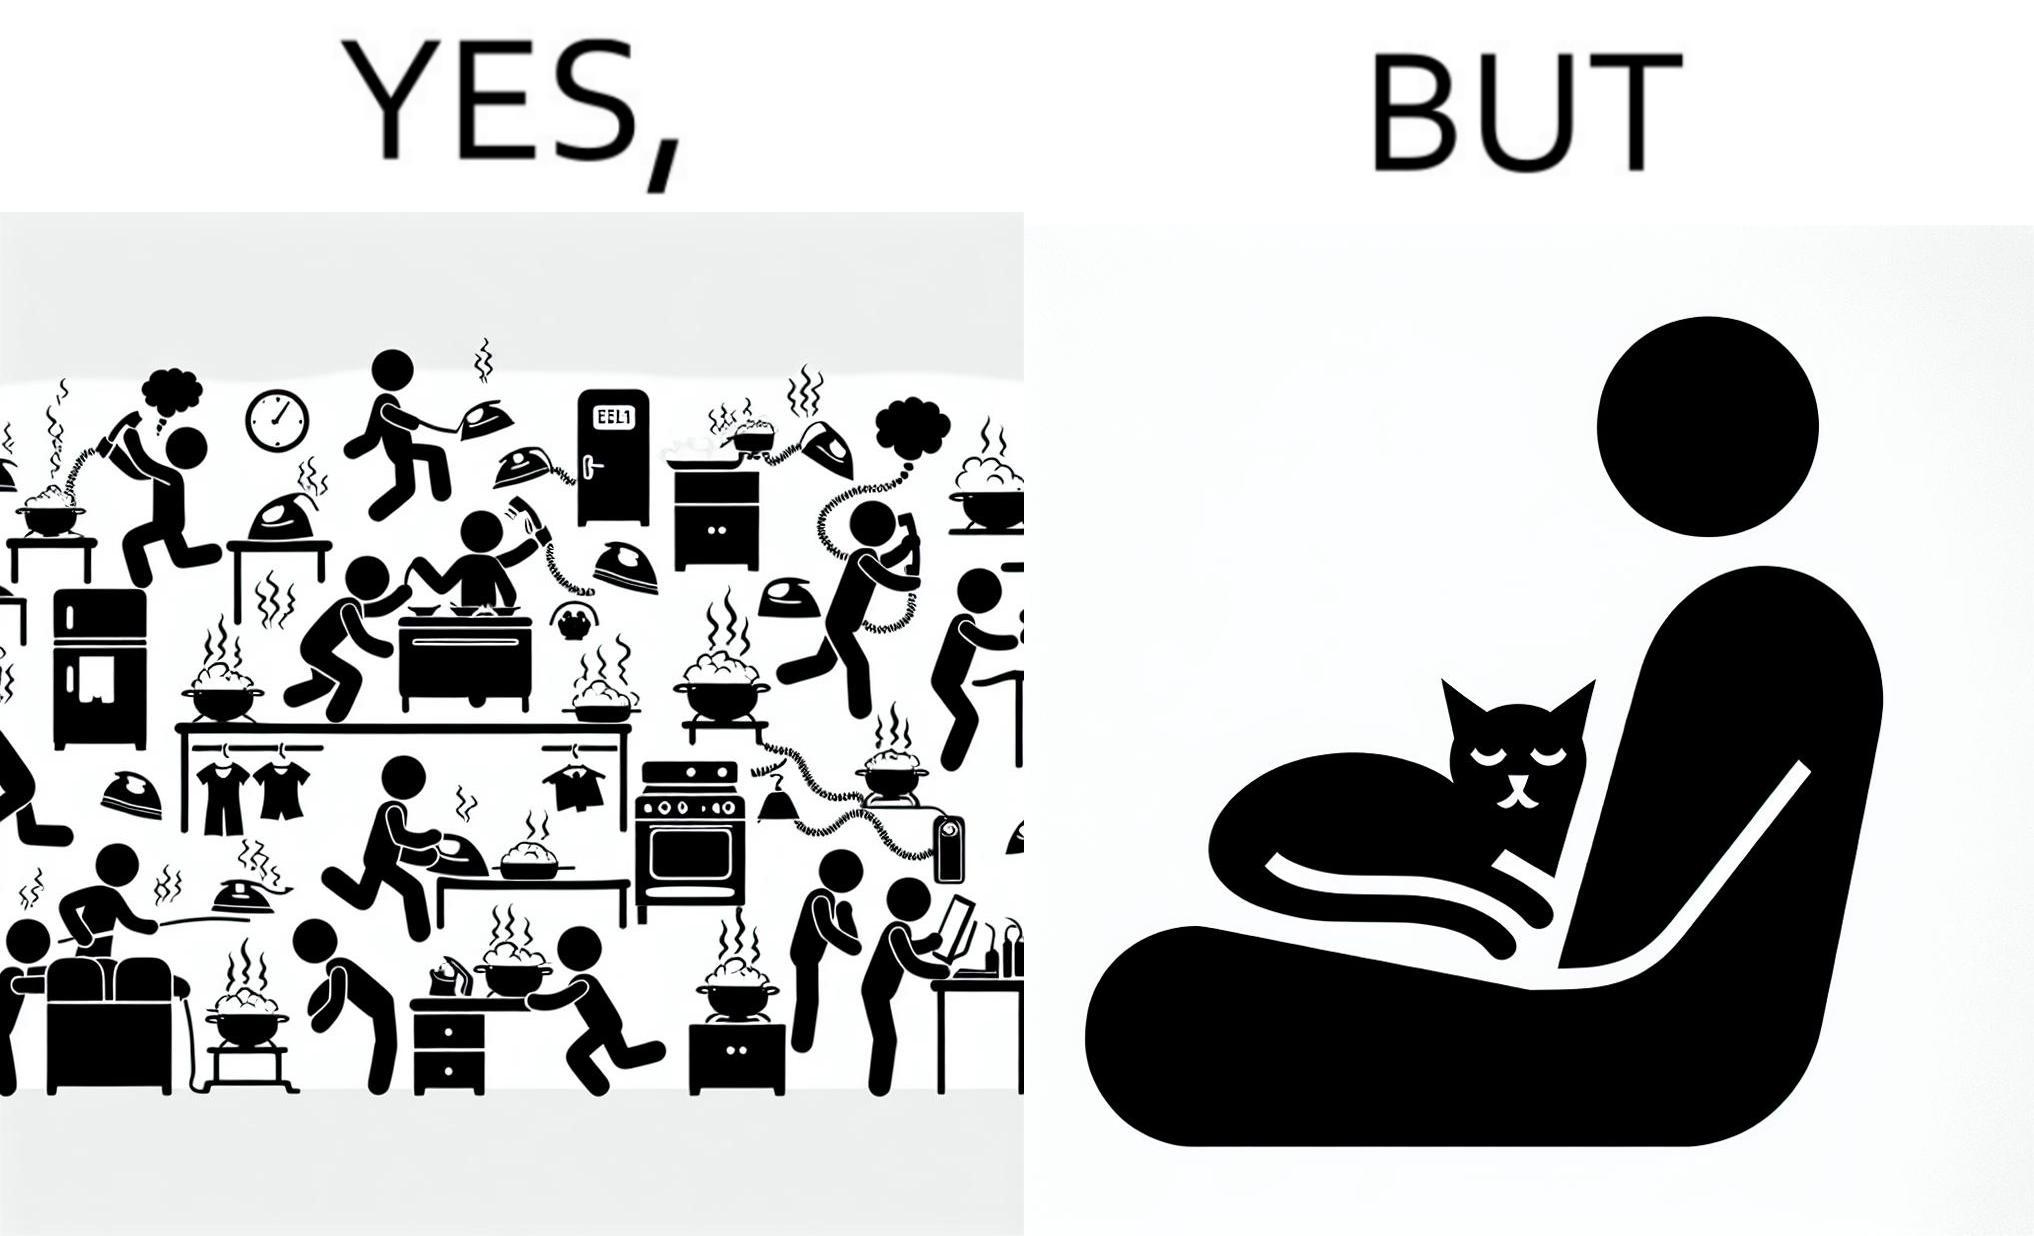Is this image satirical or non-satirical? Yes, this image is satirical. 